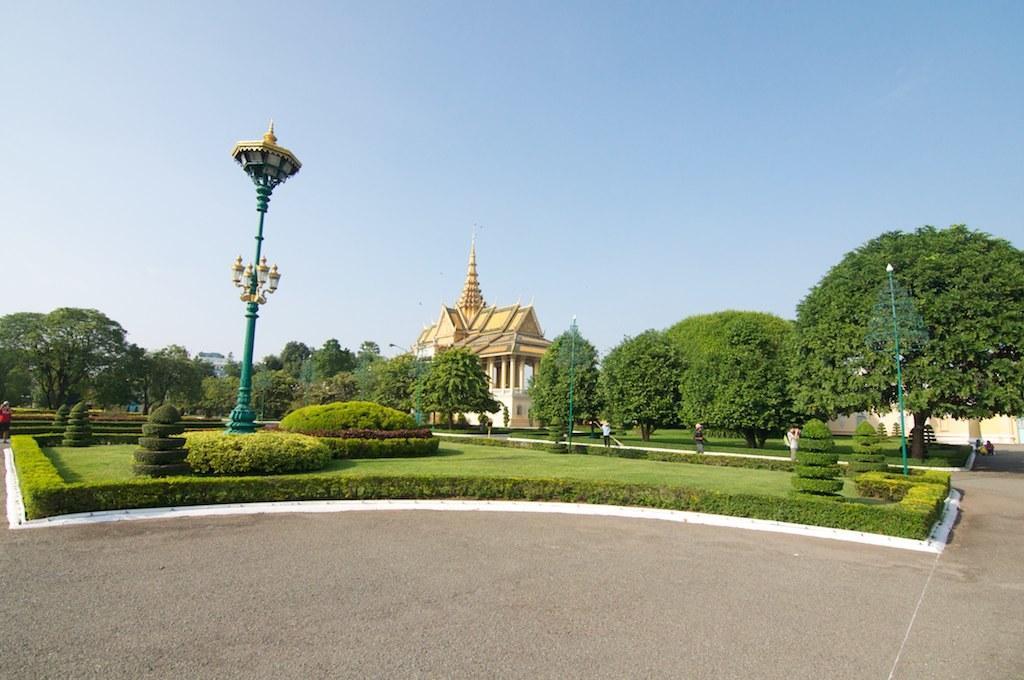In one or two sentences, can you explain what this image depicts? In this image I can see the road. I can see the plants. In the background, I can see the trees, a house and the sky. 